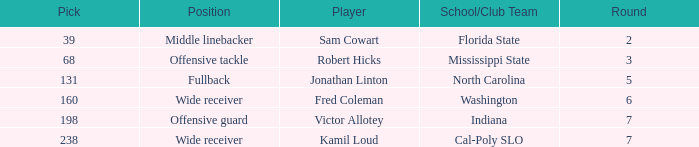Which Round has a School/Club Team of cal-poly slo, and a Pick smaller than 238? None. 